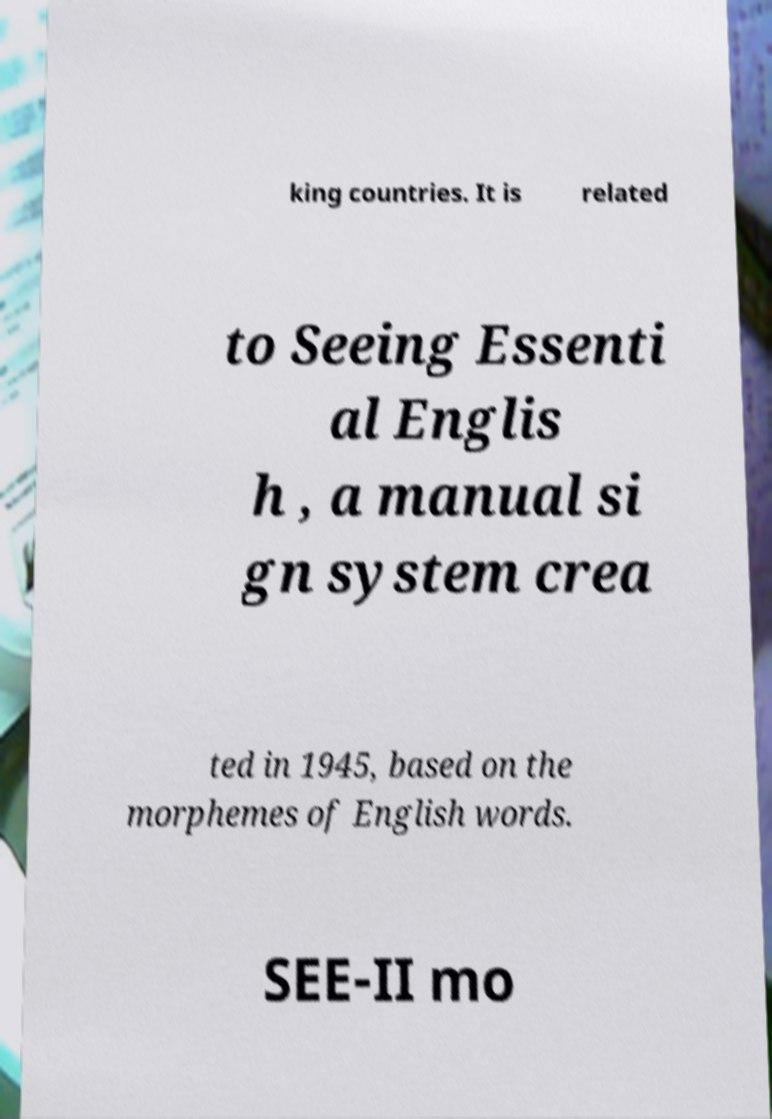Could you assist in decoding the text presented in this image and type it out clearly? king countries. It is related to Seeing Essenti al Englis h , a manual si gn system crea ted in 1945, based on the morphemes of English words. SEE-II mo 